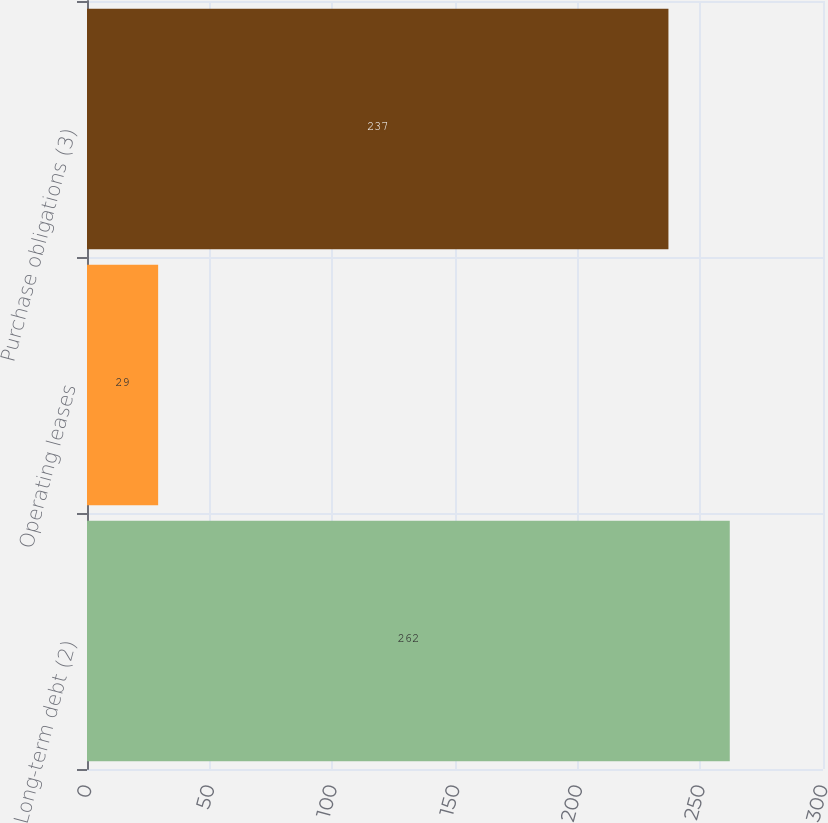<chart> <loc_0><loc_0><loc_500><loc_500><bar_chart><fcel>Long-term debt (2)<fcel>Operating leases<fcel>Purchase obligations (3)<nl><fcel>262<fcel>29<fcel>237<nl></chart> 